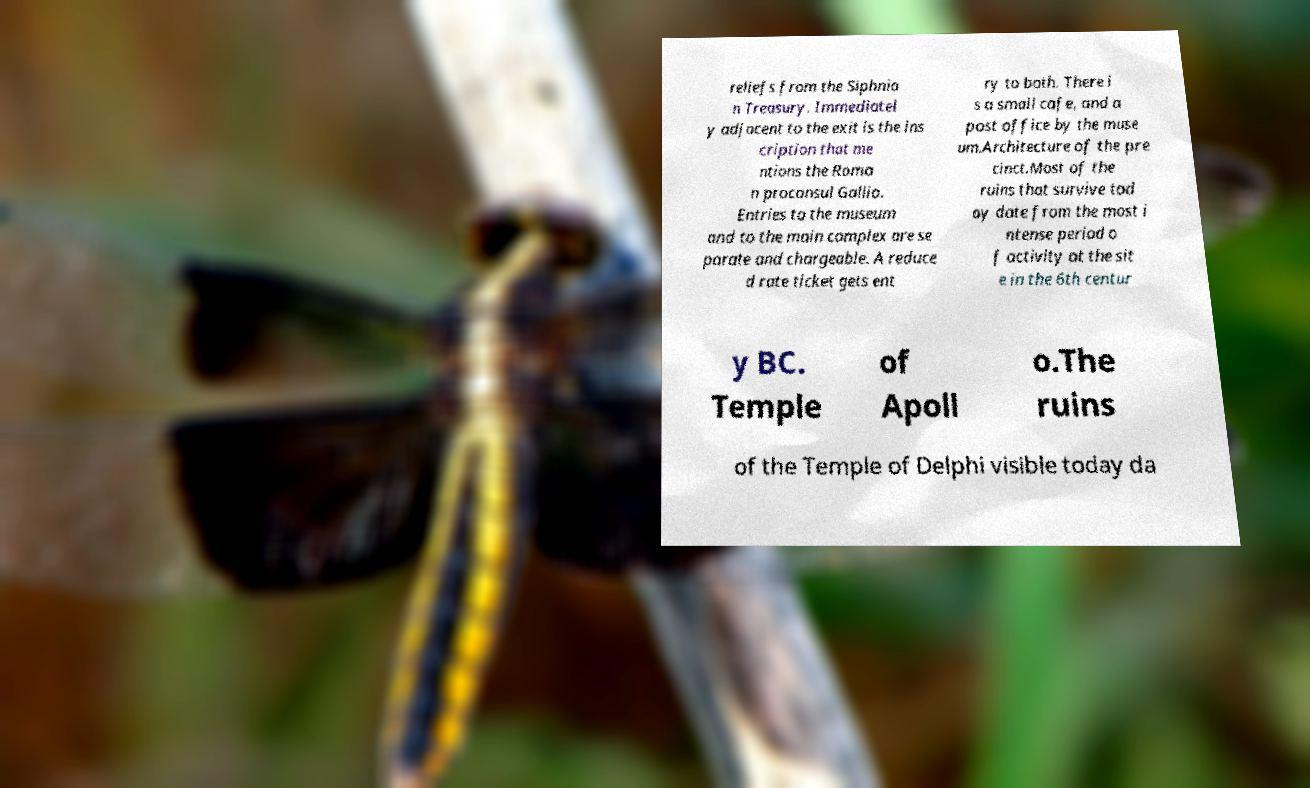There's text embedded in this image that I need extracted. Can you transcribe it verbatim? reliefs from the Siphnia n Treasury. Immediatel y adjacent to the exit is the ins cription that me ntions the Roma n proconsul Gallio. Entries to the museum and to the main complex are se parate and chargeable. A reduce d rate ticket gets ent ry to both. There i s a small cafe, and a post office by the muse um.Architecture of the pre cinct.Most of the ruins that survive tod ay date from the most i ntense period o f activity at the sit e in the 6th centur y BC. Temple of Apoll o.The ruins of the Temple of Delphi visible today da 